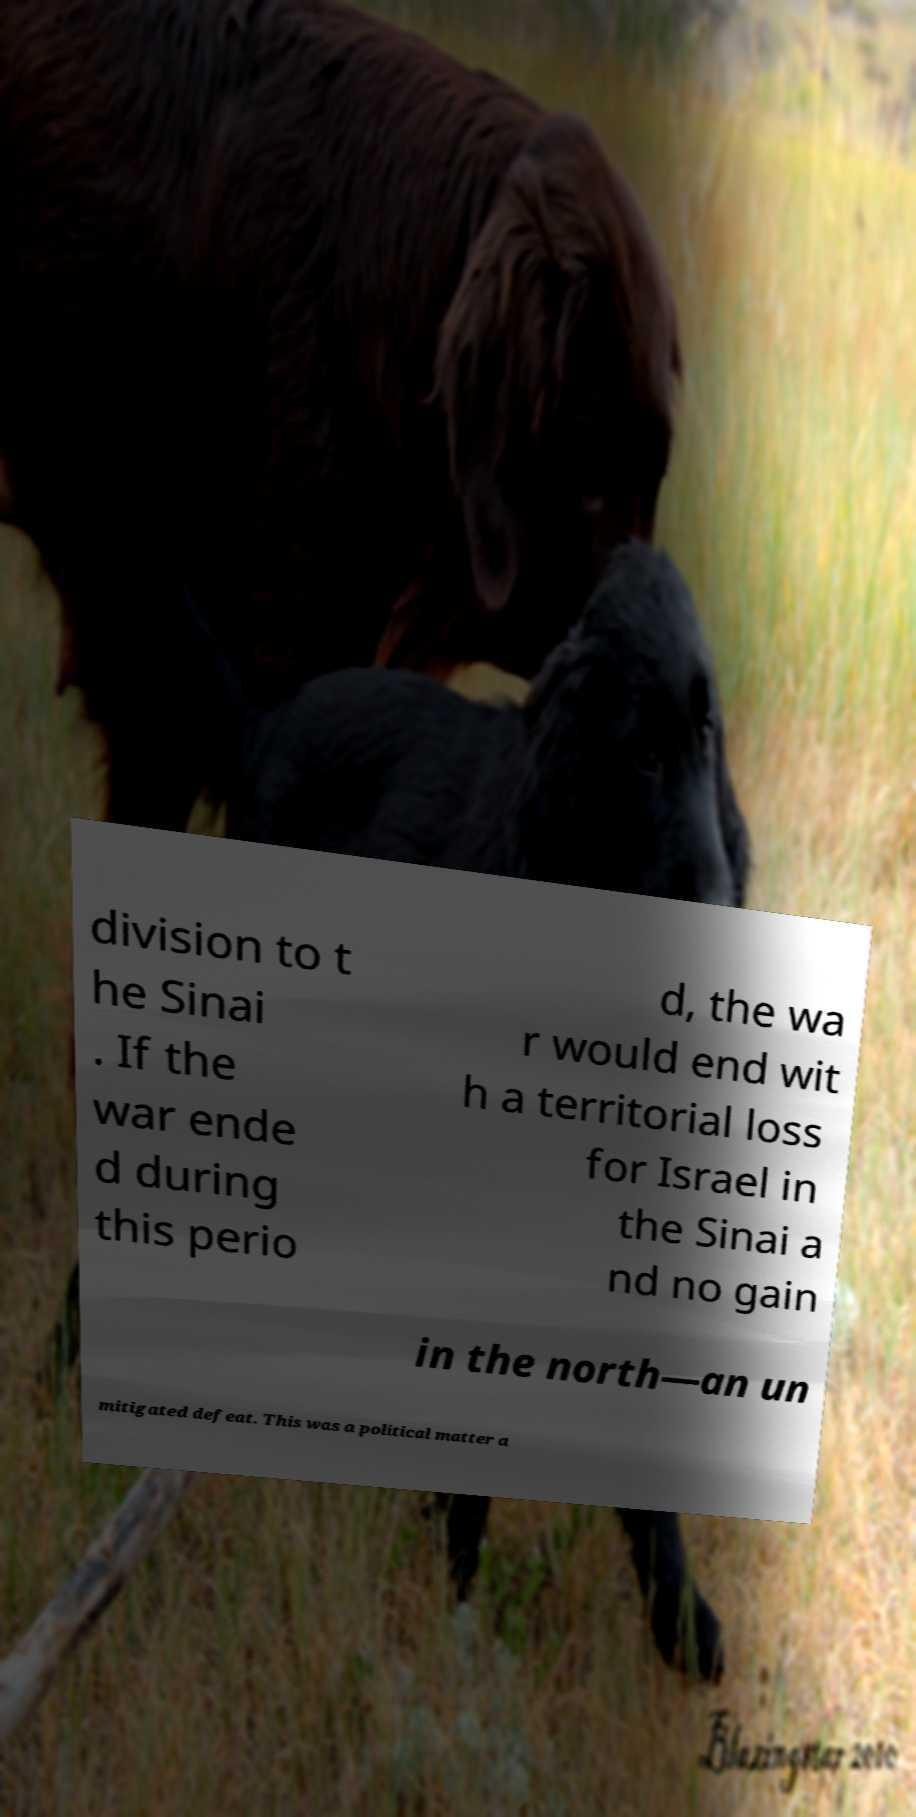Could you extract and type out the text from this image? division to t he Sinai . If the war ende d during this perio d, the wa r would end wit h a territorial loss for Israel in the Sinai a nd no gain in the north—an un mitigated defeat. This was a political matter a 